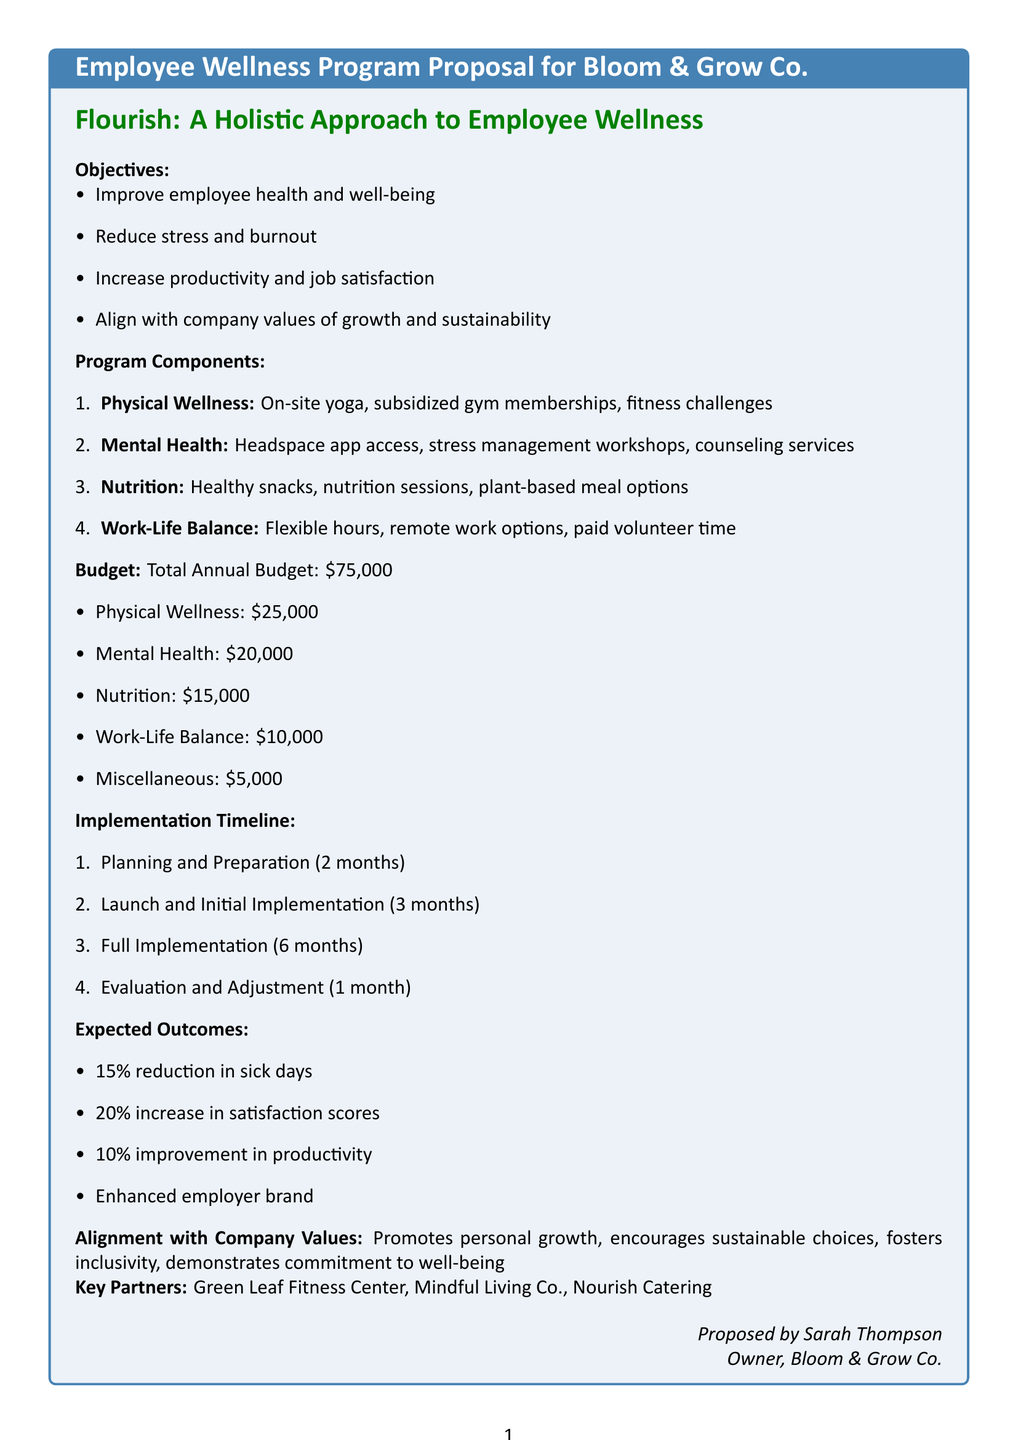What is the title of the memo? The title of the memo is stated at the beginning of the document as "Employee Wellness Program Proposal for Bloom & Grow Co."
Answer: Employee Wellness Program Proposal for Bloom & Grow Co Who is the owner proposing this program? The owner proposing the program is mentioned at the end of the document as Sarah Thompson.
Answer: Sarah Thompson What is the total annual budget for the wellness program? The total annual budget is explicitly stated in the budget section of the document as $75,000.
Answer: $75,000 How long is the planning and preparation phase? The duration of the planning and preparation phase is mentioned in the implementation timeline section as 2 months.
Answer: 2 months What component includes "Access to Headspace meditation app"? The component that includes this activity is specified in the mental health section of the program components.
Answer: Mental Health What is one expected outcome related to employee sick days? One expected outcome related to employee sick days is a 15% reduction in sick days, as stated in the expected outcomes section.
Answer: 15% reduction in sick days Which company is providing gym memberships? The key partner providing gym memberships is mentioned in the document as Green Leaf Fitness Center.
Answer: Green Leaf Fitness Center How many phases are listed in the implementation timeline? The implementation timeline lists a total of four phases.
Answer: Four phases What is one value that the wellness program aligns with? One of the values that the wellness program aligns with is mentioned as promoting personal growth.
Answer: Promotes personal growth 